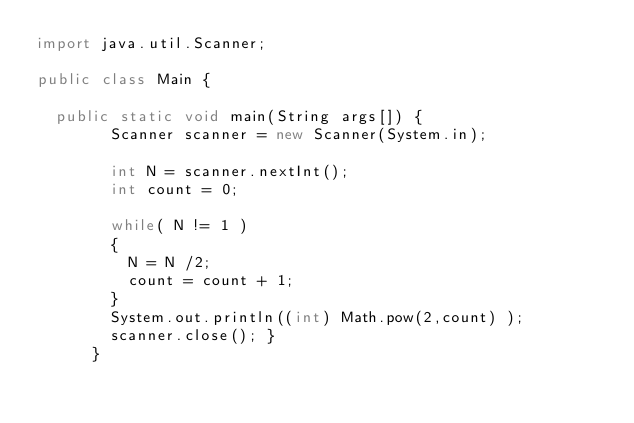Convert code to text. <code><loc_0><loc_0><loc_500><loc_500><_Java_>import java.util.Scanner;

public class Main {
	  
	public static void main(String args[]) {
		    Scanner scanner = new Scanner(System.in);
		    
		    int N = scanner.nextInt();
		    int count = 0;
		    
		    while( N != 1 ) 
		    {
		    	N = N /2;
		    	count = count + 1;
		    }
		    System.out.println((int) Math.pow(2,count) );
		    scanner.close(); }
		  }</code> 